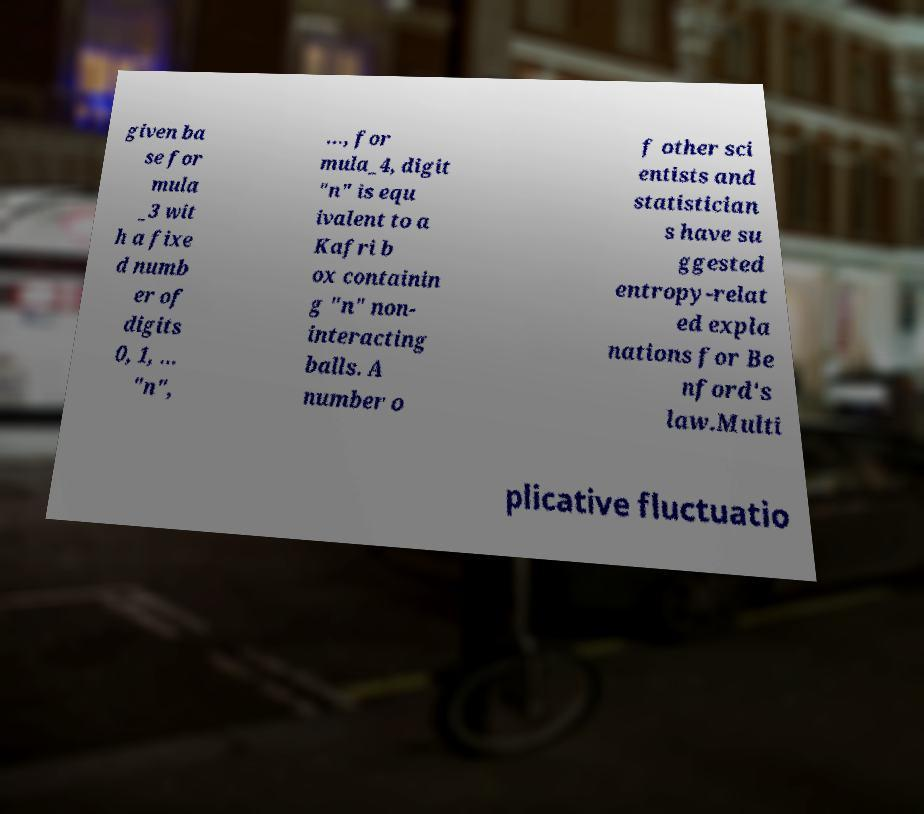Can you read and provide the text displayed in the image?This photo seems to have some interesting text. Can you extract and type it out for me? given ba se for mula _3 wit h a fixe d numb er of digits 0, 1, ... "n", ..., for mula_4, digit "n" is equ ivalent to a Kafri b ox containin g "n" non- interacting balls. A number o f other sci entists and statistician s have su ggested entropy-relat ed expla nations for Be nford's law.Multi plicative fluctuatio 